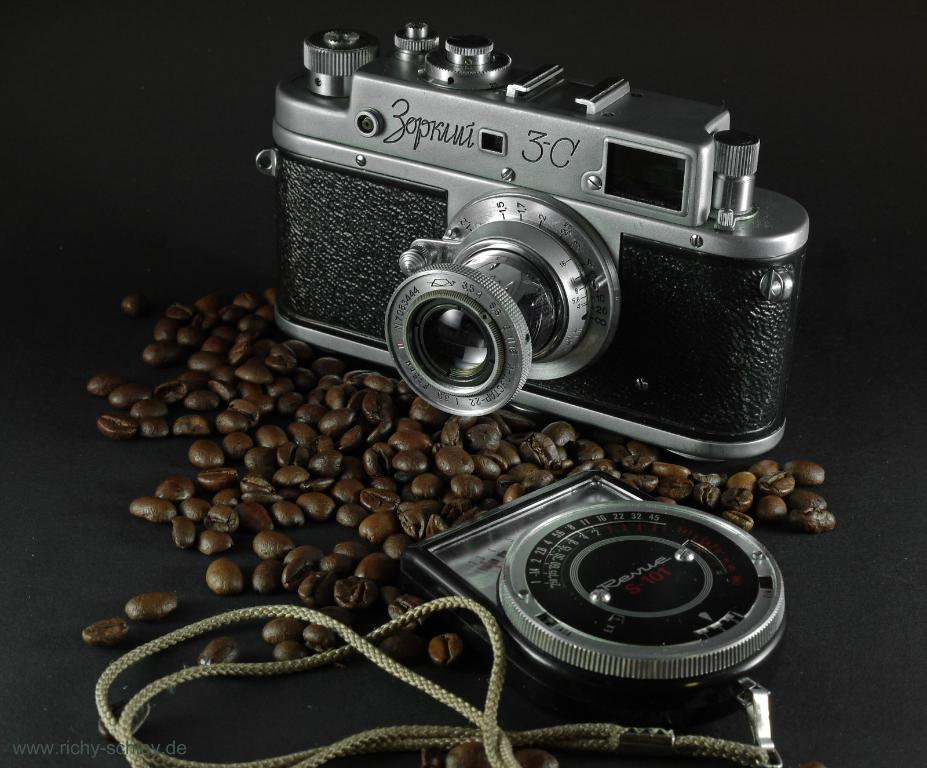What is the main object in the image? There is a camera in the image. What part of the camera is visible in the image? There is a lens in the image. What other object can be seen in the image? There is a rope in the image. What type of small, round objects are present in the image? Coffee beans are present in the image. What is the color of the surface in the image? The surface in the image is black. How many tickets are visible in the image? There are no tickets present in the image. What type of tail can be seen on the camera in the image? There is no tail present on the camera in the image. What type of building is visible in the image? There is no building visible in the image. 